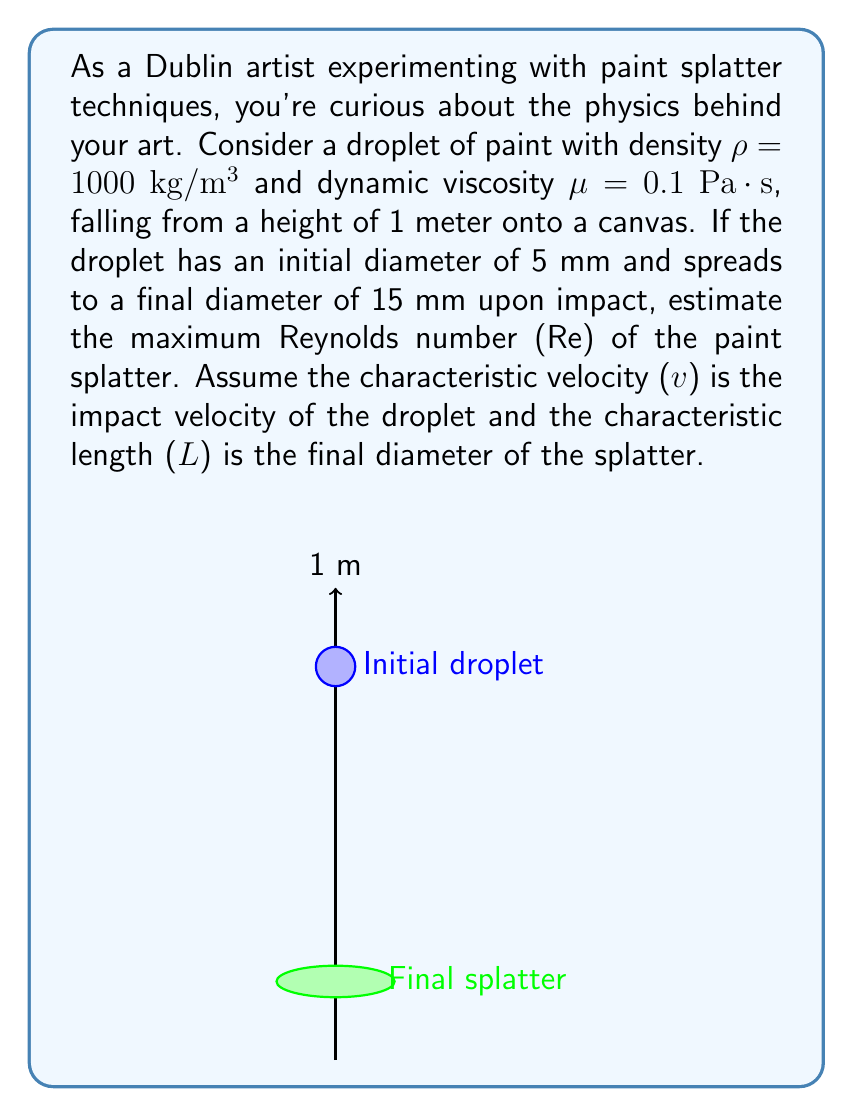Solve this math problem. To solve this problem, we'll follow these steps:

1) First, we need to calculate the impact velocity of the paint droplet. We can use the equation for free fall:

   $$v = \sqrt{2gh}$$

   where g is the acceleration due to gravity (9.8 m/s²) and h is the height (1 m).

   $$v = \sqrt{2 * 9.8 * 1} = 4.43 \text{ m/s}$$

2) Now we have all the parameters to calculate the Reynolds number. The Reynolds number is given by:

   $$Re = \frac{\rho vL}{\mu}$$

   where ρ is the density, v is the velocity, L is the characteristic length, and μ is the dynamic viscosity.

3) We'll use the final diameter of the splatter as the characteristic length:
   
   L = 15 mm = 0.015 m

4) Substituting all values into the Reynolds number equation:

   $$Re = \frac{1000 * 4.43 * 0.015}{0.1} = 664.5$$

5) Therefore, the maximum Reynolds number of the paint splatter is approximately 665.
Answer: 665 